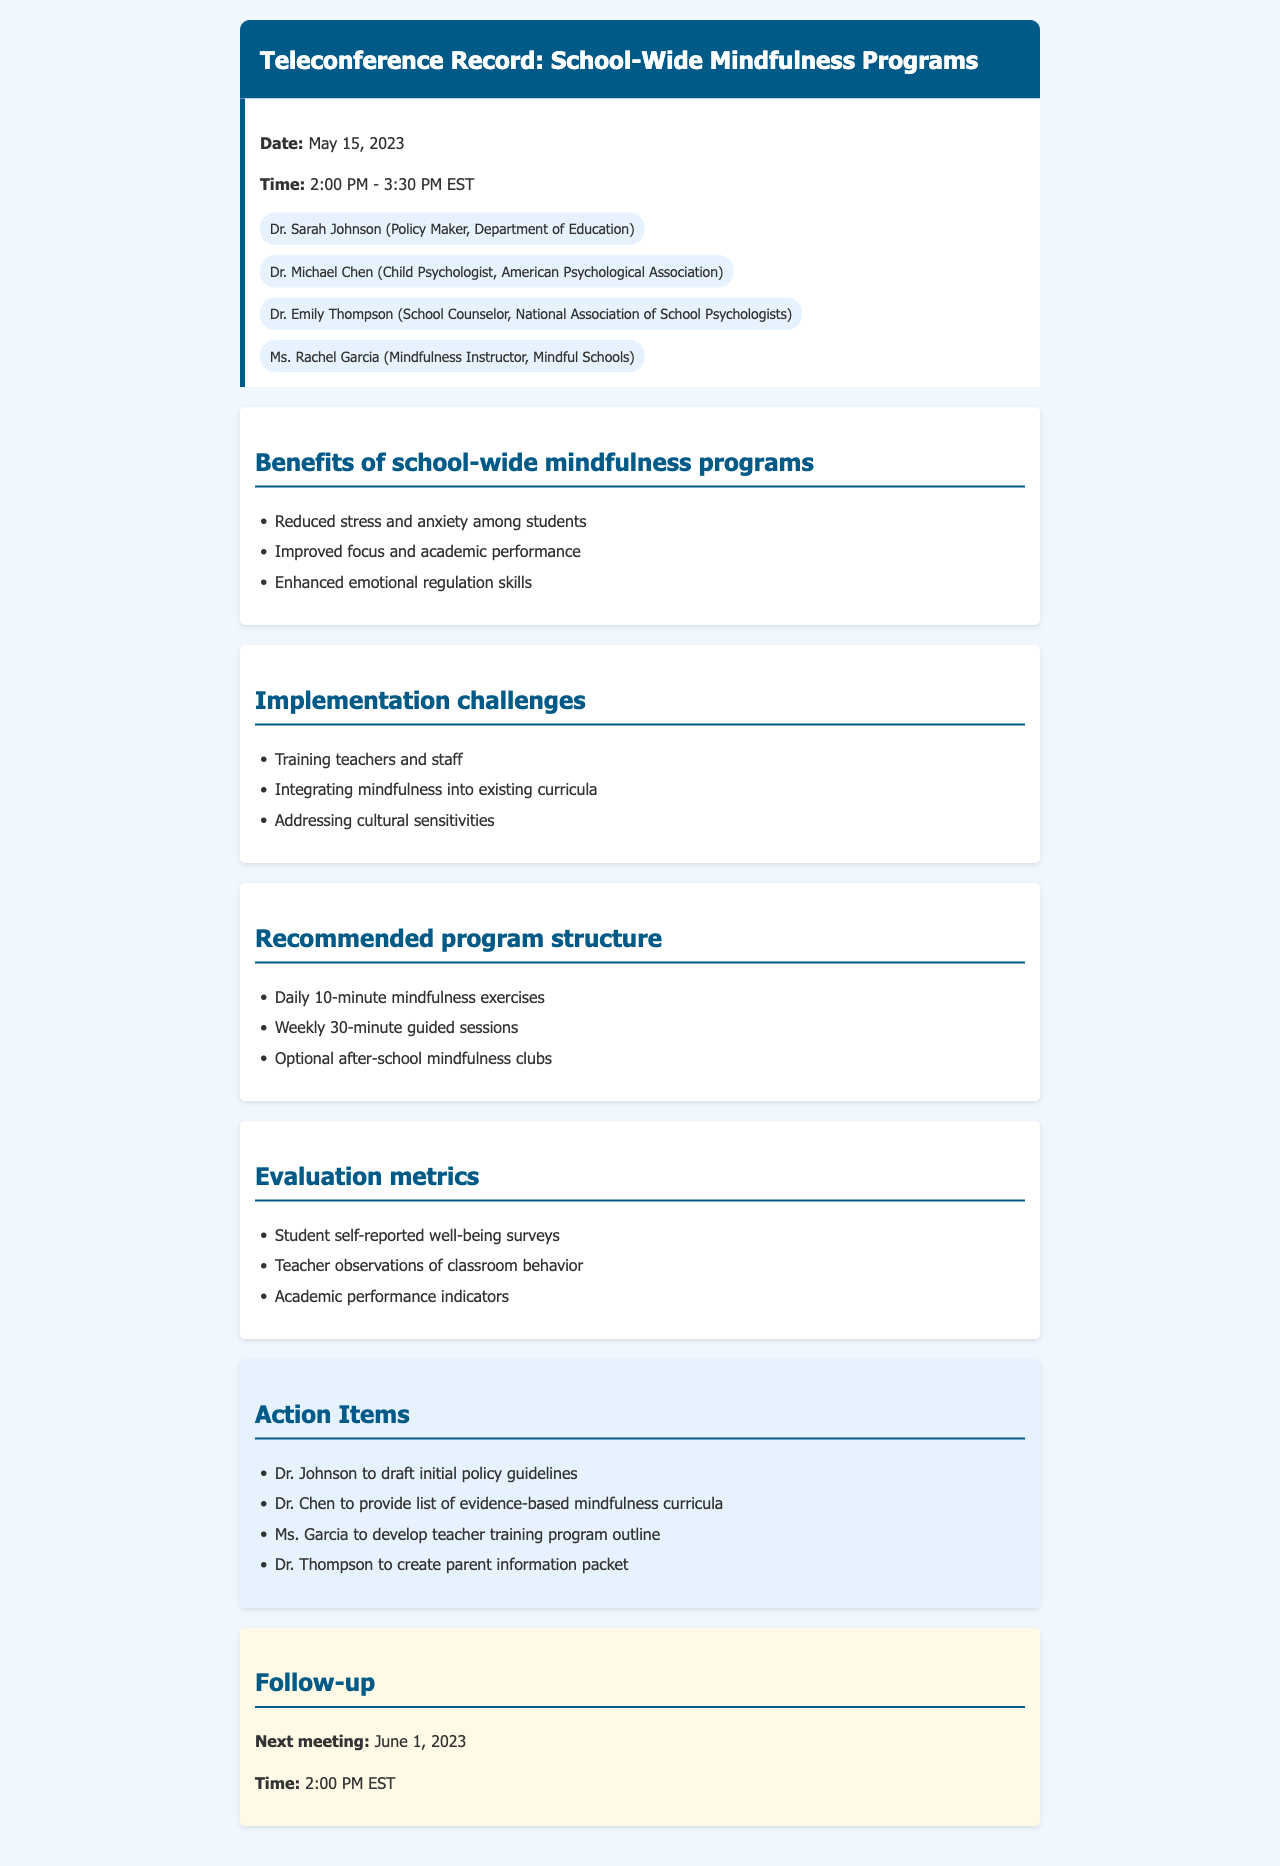What is the date of the teleconference? The date of the teleconference is stated at the beginning of the document.
Answer: May 15, 2023 Who is the mindfulness instructor participating in the call? The document lists the participants, including their roles.
Answer: Ms. Rachel Garcia What is one benefit of school-wide mindfulness programs mentioned? The document provides a list of benefits associated with the programs.
Answer: Reduced stress and anxiety among students What is one challenge of implementing mindfulness programs in schools? The challenges are detailed in a section of the document.
Answer: Training teachers and staff How long is the next meeting scheduled for? The document indicates the time for the next meeting.
Answer: 2:00 PM EST What is one method for evaluating the mindfulness program's success? Evaluation metrics are listed in a specific section of the document.
Answer: Student self-reported well-being surveys What is the recommended duration for daily mindfulness exercises? The document specifies the structure of the program, including exercise duration.
Answer: 10-minute Who is responsible for creating the parent information packet? The action items section reveals the responsibilities assigned to participants.
Answer: Dr. Thompson 